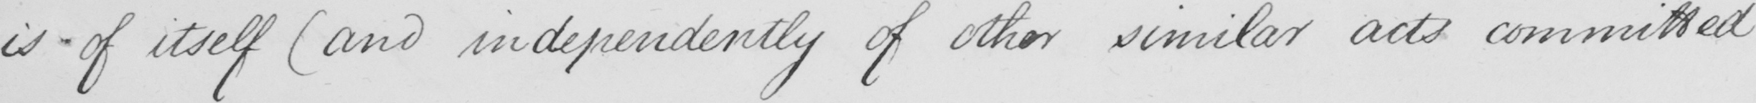Please provide the text content of this handwritten line. is  _  of itself  ( and independently of other similar acts committed 